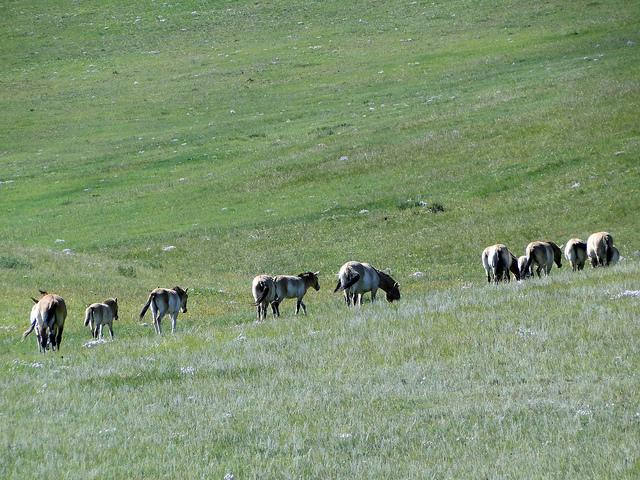What is on the grass?

Choices:
A) statues
B) animals
C) scarecrows
D) dancing seniors animals 